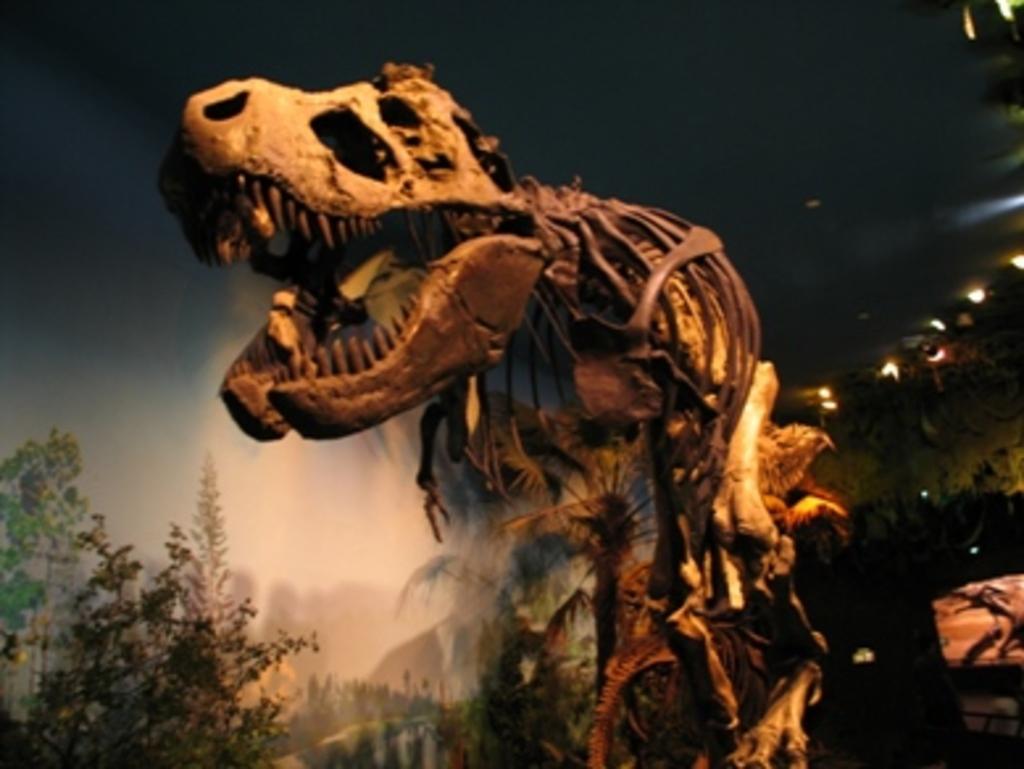Please provide a concise description of this image. In this image there is a skeleton of a dragon, in the background there are trees. 